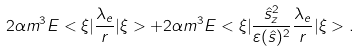Convert formula to latex. <formula><loc_0><loc_0><loc_500><loc_500>2 \alpha m ^ { 3 } E < \xi | \frac { \lambda _ { e } } { r } | \xi > + 2 \alpha m ^ { 3 } E < \xi | \frac { { \hat { s } } _ { z } ^ { 2 } } { \varepsilon ( { \hat { s } } ) ^ { 2 } } \frac { \lambda _ { e } } { r } | \xi > .</formula> 